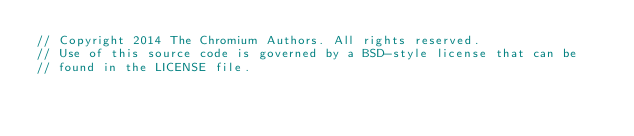<code> <loc_0><loc_0><loc_500><loc_500><_ObjectiveC_>// Copyright 2014 The Chromium Authors. All rights reserved.
// Use of this source code is governed by a BSD-style license that can be
// found in the LICENSE file.
</code> 